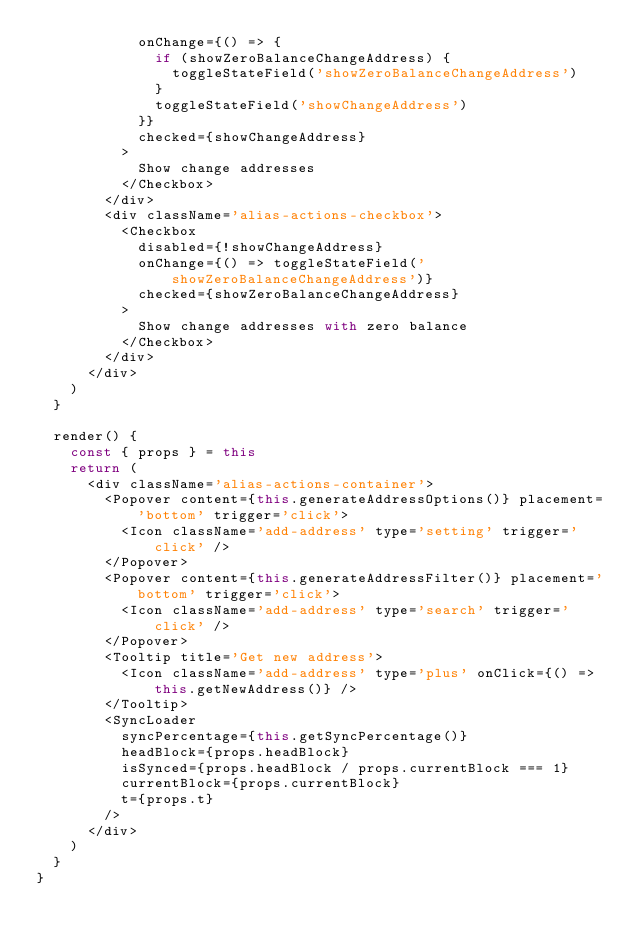<code> <loc_0><loc_0><loc_500><loc_500><_JavaScript_>            onChange={() => {
              if (showZeroBalanceChangeAddress) {
                toggleStateField('showZeroBalanceChangeAddress')
              }
              toggleStateField('showChangeAddress')
            }}
            checked={showChangeAddress}
          >
            Show change addresses
          </Checkbox>
        </div>
        <div className='alias-actions-checkbox'>
          <Checkbox
            disabled={!showChangeAddress}
            onChange={() => toggleStateField('showZeroBalanceChangeAddress')}
            checked={showZeroBalanceChangeAddress}
          >
            Show change addresses with zero balance
          </Checkbox>
        </div>
      </div>
    )
  }

  render() {
    const { props } = this
    return (
      <div className='alias-actions-container'>
        <Popover content={this.generateAddressOptions()} placement='bottom' trigger='click'>
          <Icon className='add-address' type='setting' trigger='click' />
        </Popover>
        <Popover content={this.generateAddressFilter()} placement='bottom' trigger='click'>
          <Icon className='add-address' type='search' trigger='click' />
        </Popover>
        <Tooltip title='Get new address'>
          <Icon className='add-address' type='plus' onClick={() => this.getNewAddress()} />
        </Tooltip>
        <SyncLoader
          syncPercentage={this.getSyncPercentage()}
          headBlock={props.headBlock}
          isSynced={props.headBlock / props.currentBlock === 1}
          currentBlock={props.currentBlock}
          t={props.t}
        />
      </div>
    )
  }
}
</code> 